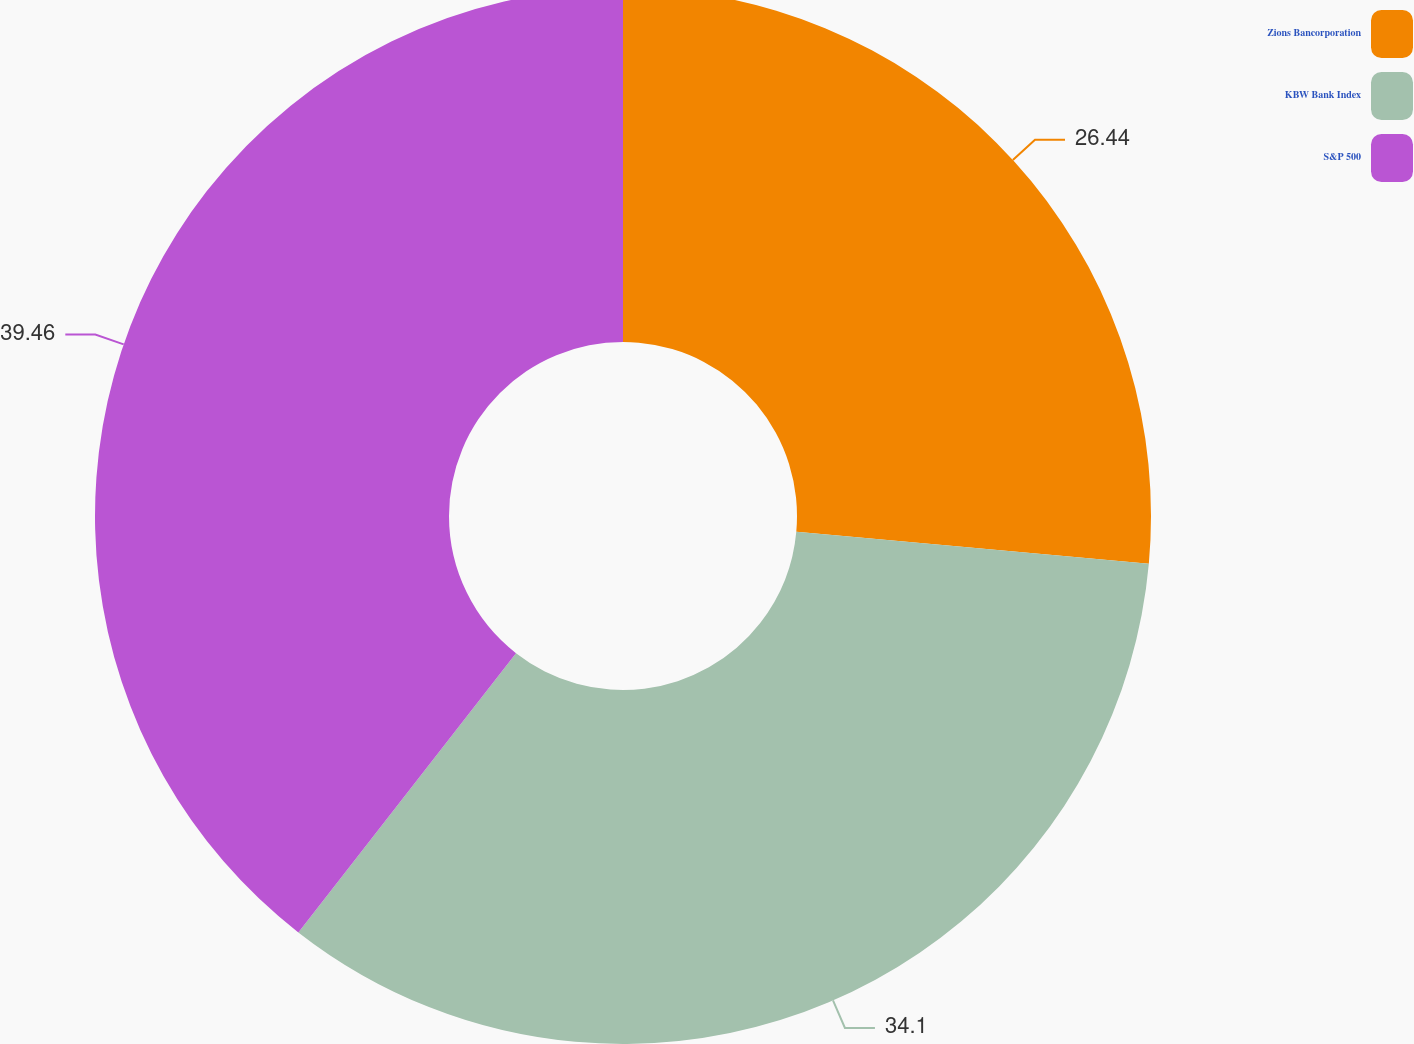Convert chart. <chart><loc_0><loc_0><loc_500><loc_500><pie_chart><fcel>Zions Bancorporation<fcel>KBW Bank Index<fcel>S&P 500<nl><fcel>26.44%<fcel>34.1%<fcel>39.46%<nl></chart> 